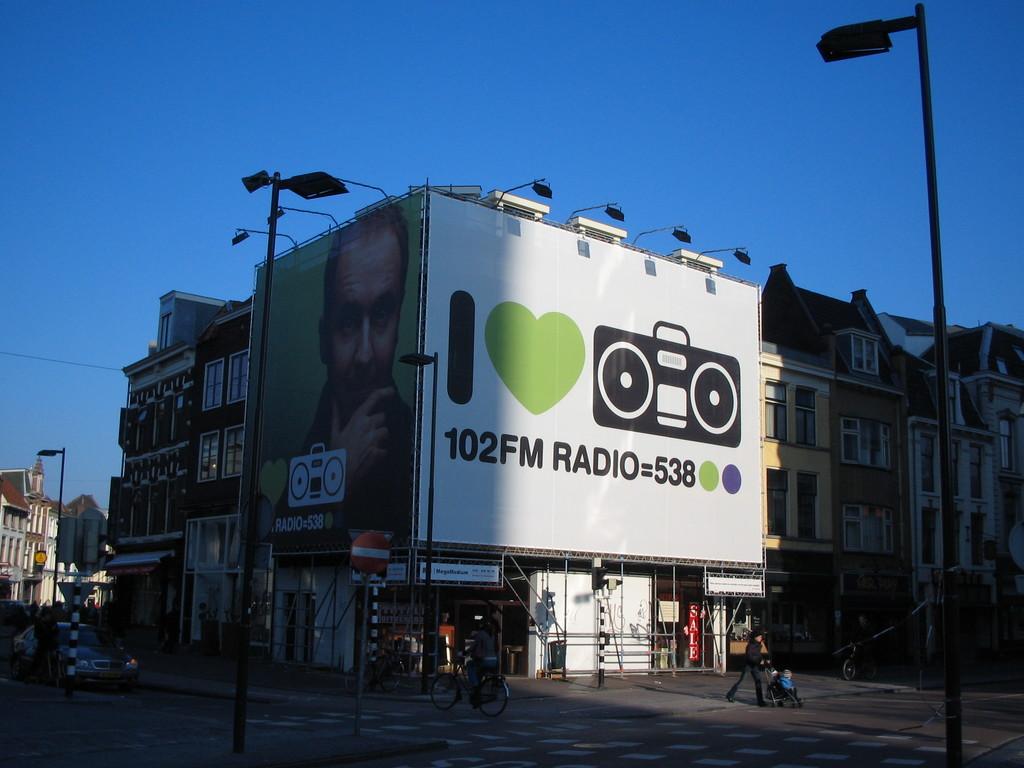What is this advertisement?
Provide a short and direct response. 102fm radio. Which radio station?
Offer a very short reply. 102fm. 